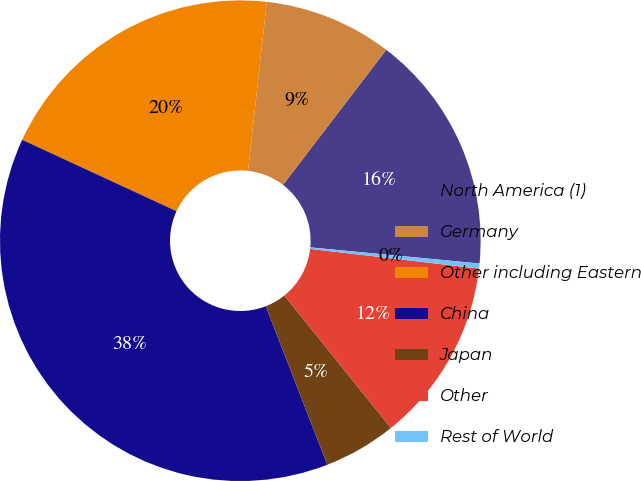Convert chart. <chart><loc_0><loc_0><loc_500><loc_500><pie_chart><fcel>North America (1)<fcel>Germany<fcel>Other including Eastern<fcel>China<fcel>Japan<fcel>Other<fcel>Rest of World<nl><fcel>16.12%<fcel>8.63%<fcel>19.86%<fcel>37.79%<fcel>4.88%<fcel>12.37%<fcel>0.34%<nl></chart> 